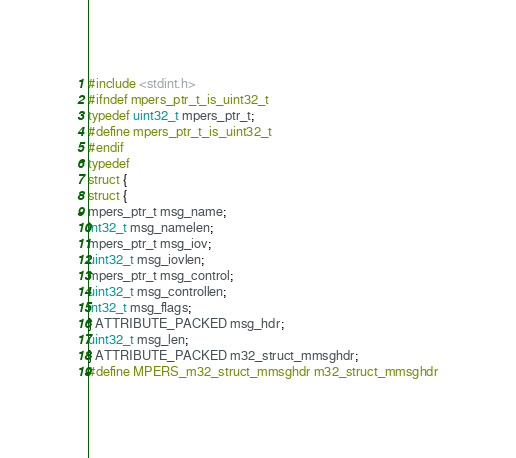<code> <loc_0><loc_0><loc_500><loc_500><_C_>#include <stdint.h>
#ifndef mpers_ptr_t_is_uint32_t
typedef uint32_t mpers_ptr_t;
#define mpers_ptr_t_is_uint32_t
#endif
typedef
struct {
struct {
mpers_ptr_t msg_name;
int32_t msg_namelen;
mpers_ptr_t msg_iov;
uint32_t msg_iovlen;
mpers_ptr_t msg_control;
uint32_t msg_controllen;
int32_t msg_flags;
} ATTRIBUTE_PACKED msg_hdr;
uint32_t msg_len;
} ATTRIBUTE_PACKED m32_struct_mmsghdr;
#define MPERS_m32_struct_mmsghdr m32_struct_mmsghdr
</code> 